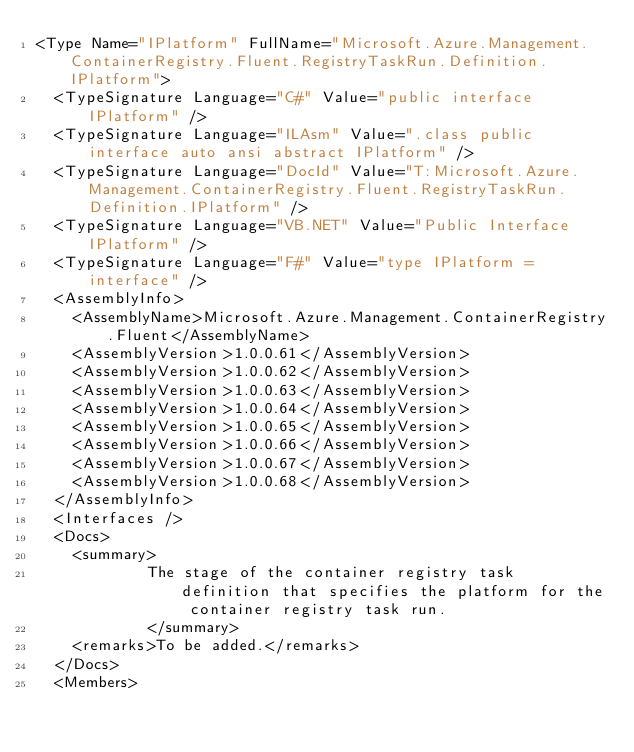Convert code to text. <code><loc_0><loc_0><loc_500><loc_500><_XML_><Type Name="IPlatform" FullName="Microsoft.Azure.Management.ContainerRegistry.Fluent.RegistryTaskRun.Definition.IPlatform">
  <TypeSignature Language="C#" Value="public interface IPlatform" />
  <TypeSignature Language="ILAsm" Value=".class public interface auto ansi abstract IPlatform" />
  <TypeSignature Language="DocId" Value="T:Microsoft.Azure.Management.ContainerRegistry.Fluent.RegistryTaskRun.Definition.IPlatform" />
  <TypeSignature Language="VB.NET" Value="Public Interface IPlatform" />
  <TypeSignature Language="F#" Value="type IPlatform = interface" />
  <AssemblyInfo>
    <AssemblyName>Microsoft.Azure.Management.ContainerRegistry.Fluent</AssemblyName>
    <AssemblyVersion>1.0.0.61</AssemblyVersion>
    <AssemblyVersion>1.0.0.62</AssemblyVersion>
    <AssemblyVersion>1.0.0.63</AssemblyVersion>
    <AssemblyVersion>1.0.0.64</AssemblyVersion>
    <AssemblyVersion>1.0.0.65</AssemblyVersion>
    <AssemblyVersion>1.0.0.66</AssemblyVersion>
    <AssemblyVersion>1.0.0.67</AssemblyVersion>
    <AssemblyVersion>1.0.0.68</AssemblyVersion>
  </AssemblyInfo>
  <Interfaces />
  <Docs>
    <summary>
            The stage of the container registry task definition that specifies the platform for the container registry task run.
            </summary>
    <remarks>To be added.</remarks>
  </Docs>
  <Members></code> 